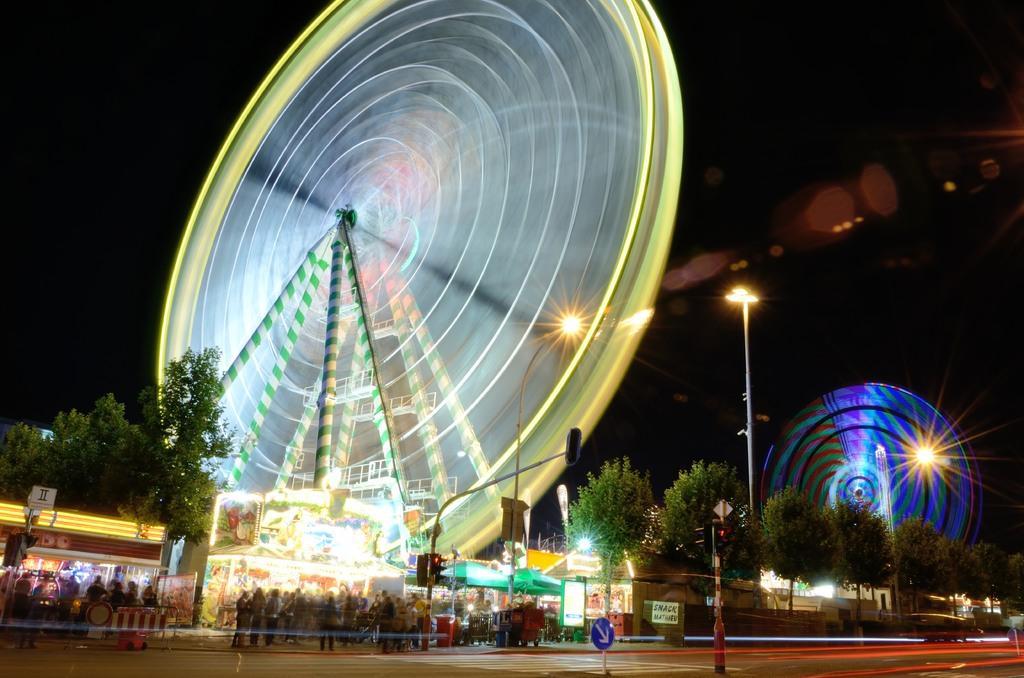Describe this image in one or two sentences. This image is clicked on the road. Beside the road there are street light poles, traffic light poles and sign boards. There are people standing on the walkway. Behind them there are stalls and trees. There are giant wheels in the image. At the top there is the sky. 